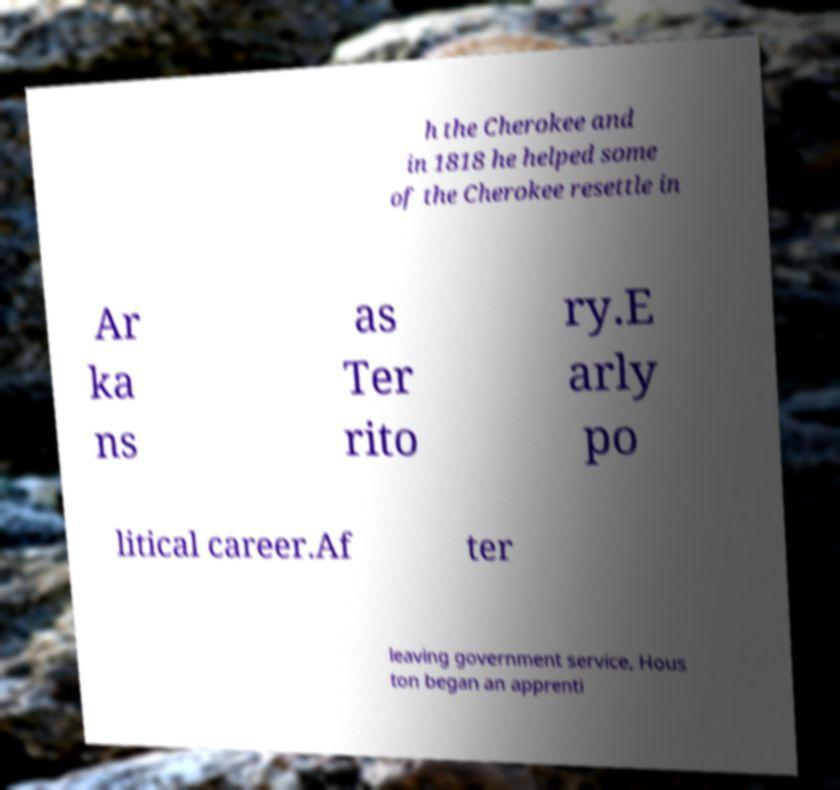Could you extract and type out the text from this image? h the Cherokee and in 1818 he helped some of the Cherokee resettle in Ar ka ns as Ter rito ry.E arly po litical career.Af ter leaving government service, Hous ton began an apprenti 